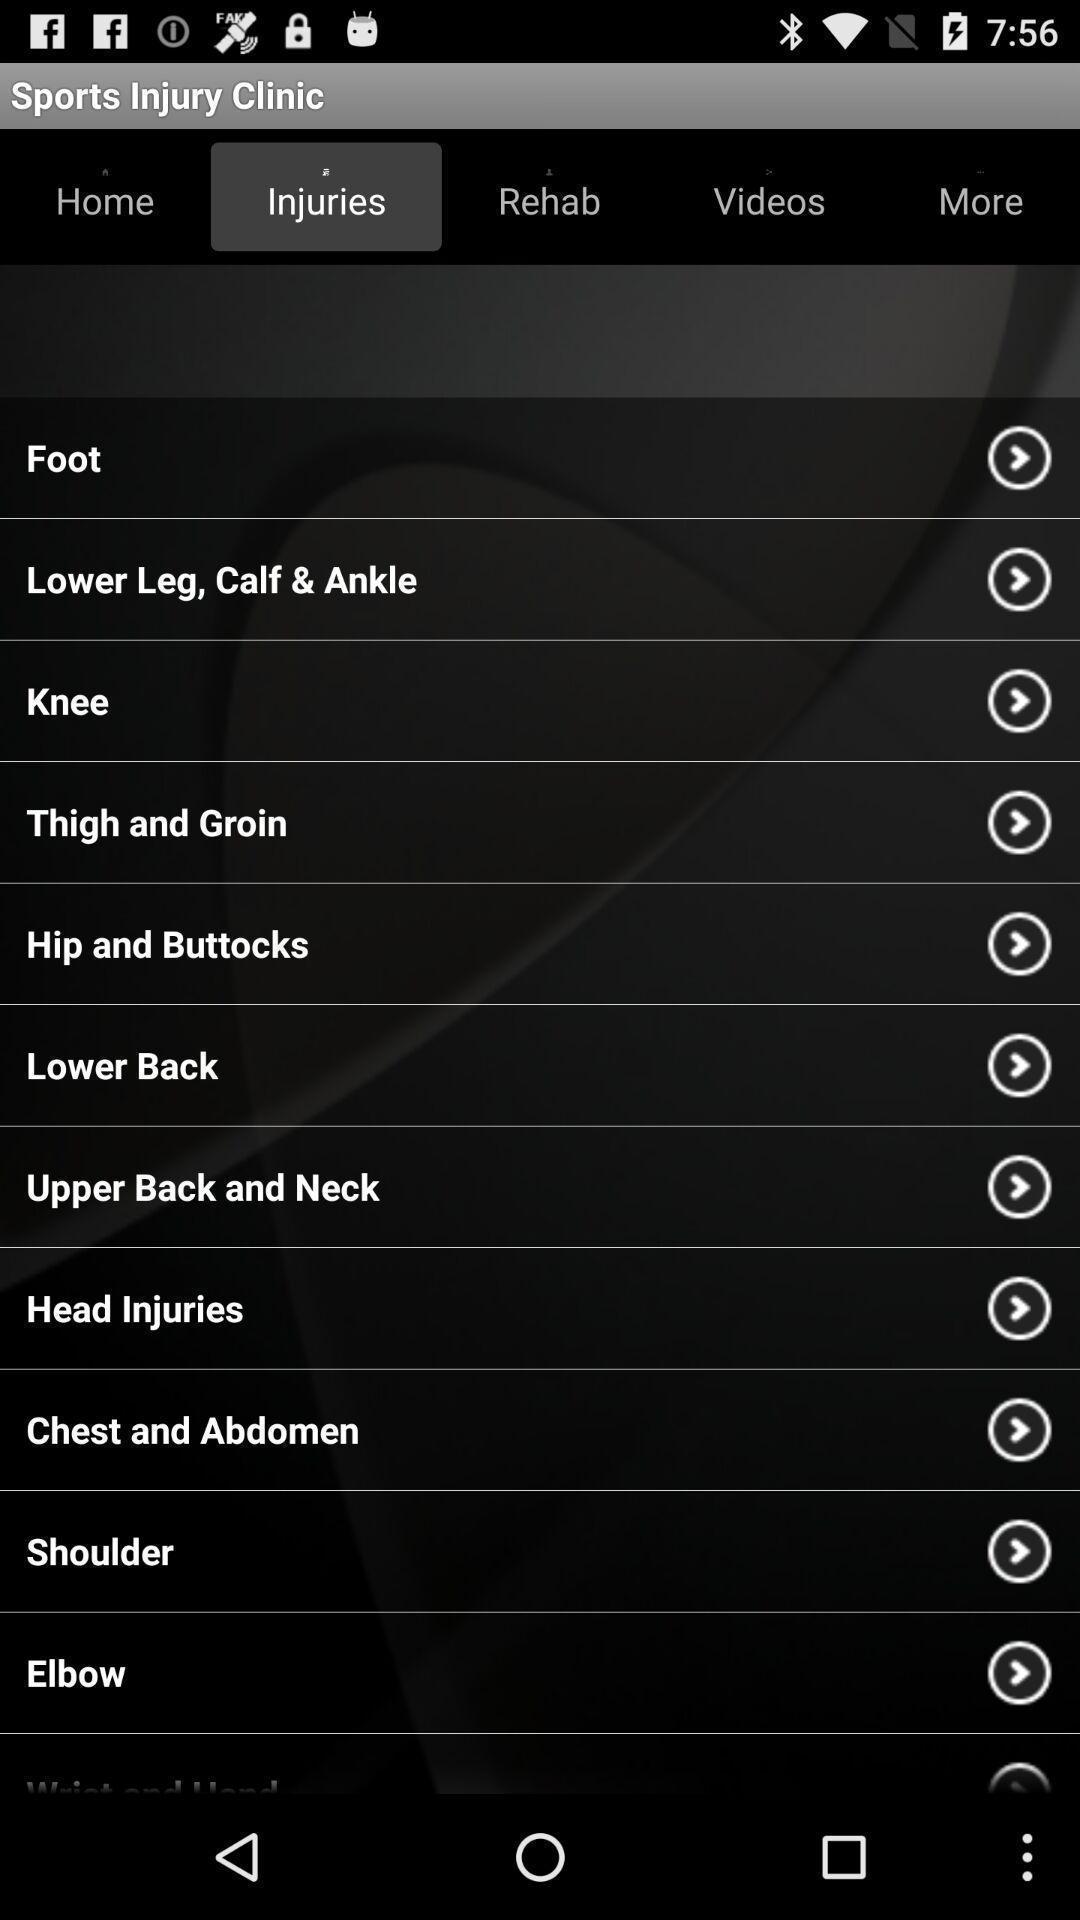Explain what's happening in this screen capture. Page displaying with different body parts in injuries tab. 